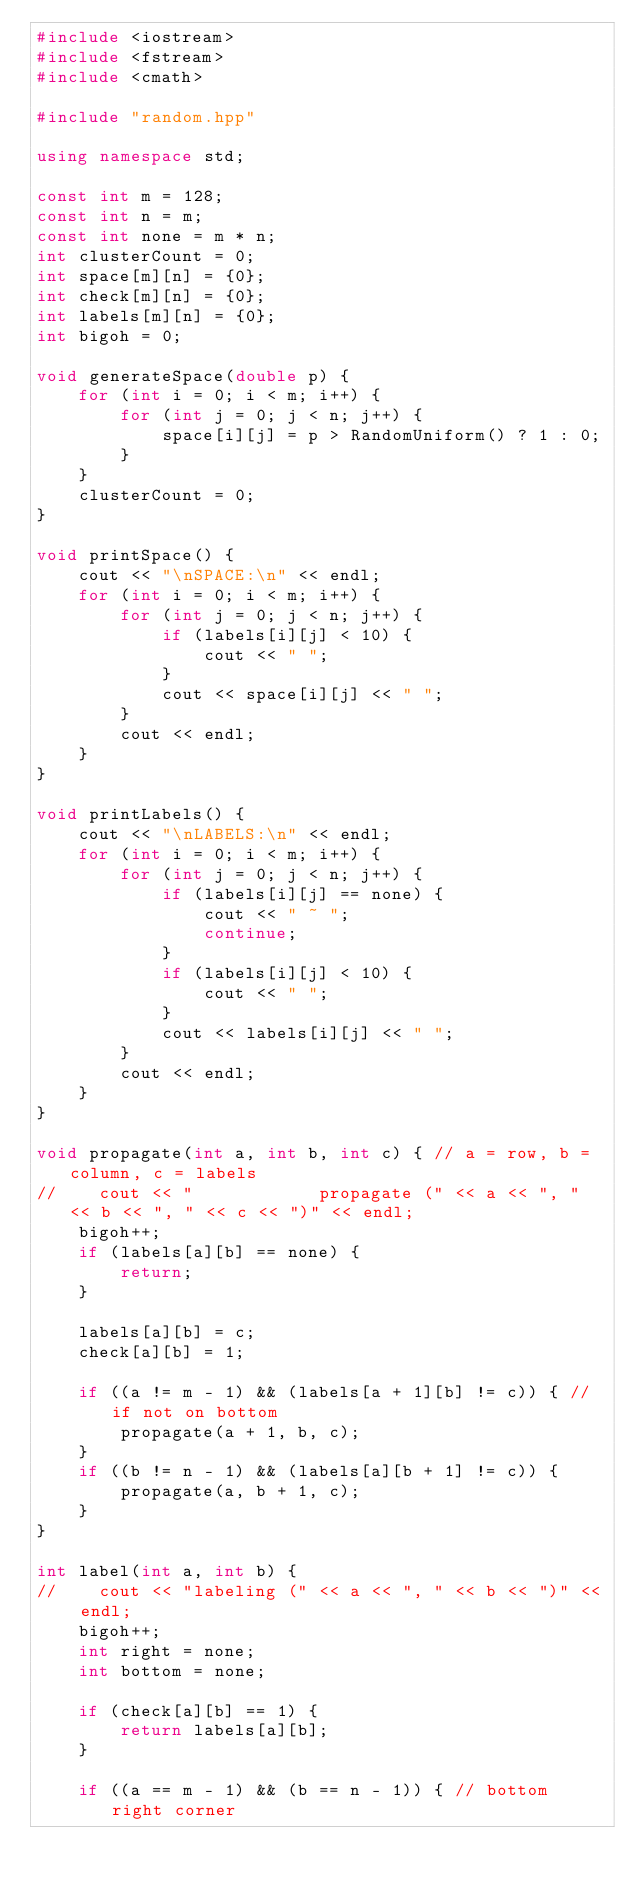<code> <loc_0><loc_0><loc_500><loc_500><_C++_>#include <iostream>
#include <fstream>
#include <cmath>

#include "random.hpp"

using namespace std;

const int m = 128;
const int n = m;
const int none = m * n;
int clusterCount = 0;
int space[m][n] = {0};
int check[m][n] = {0};
int labels[m][n] = {0};
int bigoh = 0;

void generateSpace(double p) {
    for (int i = 0; i < m; i++) {
        for (int j = 0; j < n; j++) {
            space[i][j] = p > RandomUniform() ? 1 : 0;
        }
    }
    clusterCount = 0;
}

void printSpace() {
    cout << "\nSPACE:\n" << endl;
    for (int i = 0; i < m; i++) {
        for (int j = 0; j < n; j++) {
            if (labels[i][j] < 10) {
                cout << " ";
            }
            cout << space[i][j] << " ";
        }
        cout << endl;
    }
}

void printLabels() {
    cout << "\nLABELS:\n" << endl;
    for (int i = 0; i < m; i++) {
        for (int j = 0; j < n; j++) {
            if (labels[i][j] == none) {
                cout << " ~ ";
                continue;
            }
            if (labels[i][j] < 10) {
                cout << " ";
            }
            cout << labels[i][j] << " ";
        }
        cout << endl;
    }
}

void propagate(int a, int b, int c) { // a = row, b = column, c = labels
//    cout << "            propagate (" << a << ", " << b << ", " << c << ")" << endl;
    bigoh++;
    if (labels[a][b] == none) {
        return;
    }

    labels[a][b] = c;
    check[a][b] = 1;

    if ((a != m - 1) && (labels[a + 1][b] != c)) { // if not on bottom
        propagate(a + 1, b, c);
    }
    if ((b != n - 1) && (labels[a][b + 1] != c)) {
        propagate(a, b + 1, c);
    }
}

int label(int a, int b) {
//    cout << "labeling (" << a << ", " << b << ")" << endl;
    bigoh++;
    int right = none;
    int bottom = none;

    if (check[a][b] == 1) {
        return labels[a][b];
    }

    if ((a == m - 1) && (b == n - 1)) { // bottom right corner</code> 